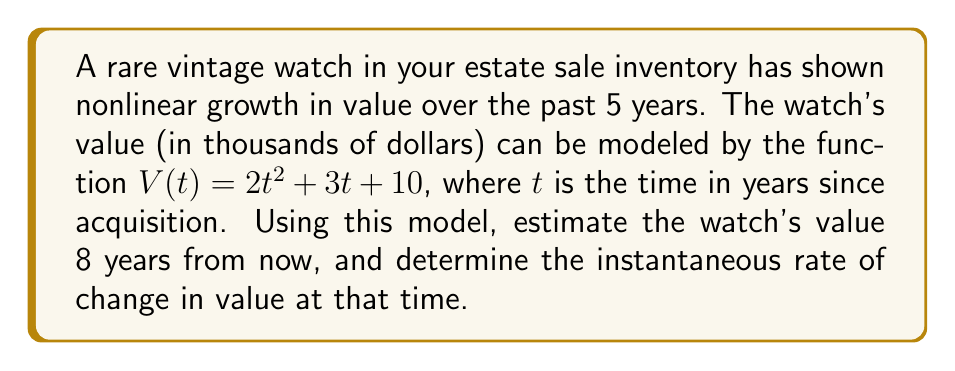Show me your answer to this math problem. 1) First, we need to calculate the value of the watch 8 years from now:
   $V(8) = 2(8)^2 + 3(8) + 10$
   $V(8) = 2(64) + 24 + 10$
   $V(8) = 128 + 24 + 10 = 162$

   So, the watch's estimated value after 8 years is $162,000.

2) To find the instantaneous rate of change at t = 8, we need to find the derivative of V(t) and evaluate it at t = 8:

   $V(t) = 2t^2 + 3t + 10$
   $V'(t) = 4t + 3$

   At t = 8:
   $V'(8) = 4(8) + 3 = 32 + 3 = 35$

   This means the instantaneous rate of change at t = 8 is $35,000 per year.

3) Therefore, 8 years from now, the watch will be worth $162,000 and its value will be increasing at a rate of $35,000 per year at that moment.
Answer: $162,000; $35,000/year 